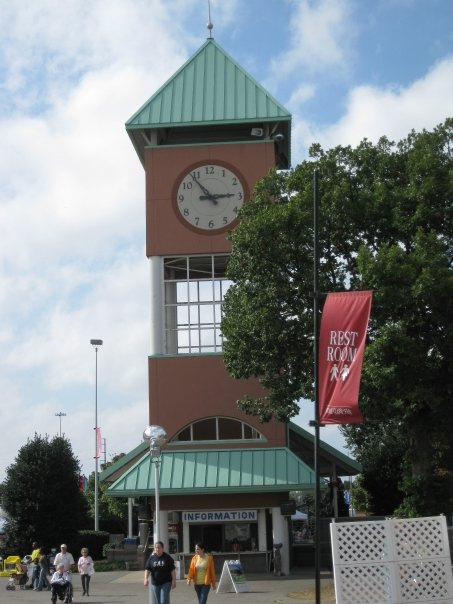<image>Who is the clockmaker? I don't know who the clockmaker is. It could be 'timex', 'rolex', 'engineer', 'acme', 'school', or 'city'. Who is the clockmaker? It is unknown who the clockmaker is. 